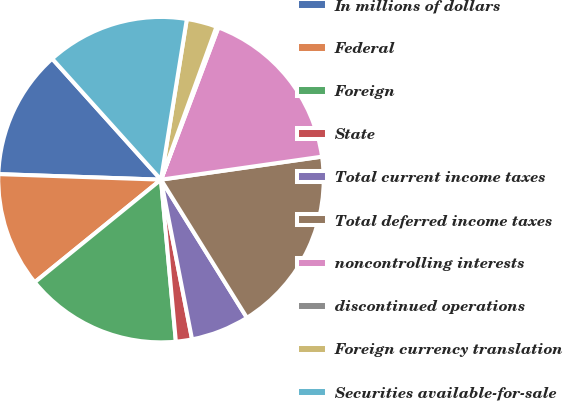Convert chart. <chart><loc_0><loc_0><loc_500><loc_500><pie_chart><fcel>In millions of dollars<fcel>Federal<fcel>Foreign<fcel>State<fcel>Total current income taxes<fcel>Total deferred income taxes<fcel>noncontrolling interests<fcel>discontinued operations<fcel>Foreign currency translation<fcel>Securities available-for-sale<nl><fcel>12.8%<fcel>11.4%<fcel>15.6%<fcel>1.6%<fcel>5.8%<fcel>18.4%<fcel>17.0%<fcel>0.2%<fcel>3.0%<fcel>14.2%<nl></chart> 